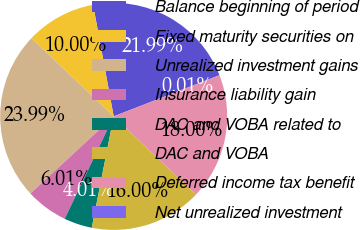<chart> <loc_0><loc_0><loc_500><loc_500><pie_chart><fcel>Balance beginning of period<fcel>Fixed maturity securities on<fcel>Unrealized investment gains<fcel>Insurance liability gain<fcel>DAC and VOBA related to<fcel>DAC and VOBA<fcel>Deferred income tax benefit<fcel>Net unrealized investment<nl><fcel>21.99%<fcel>10.0%<fcel>23.99%<fcel>6.01%<fcel>4.01%<fcel>16.0%<fcel>18.0%<fcel>0.01%<nl></chart> 